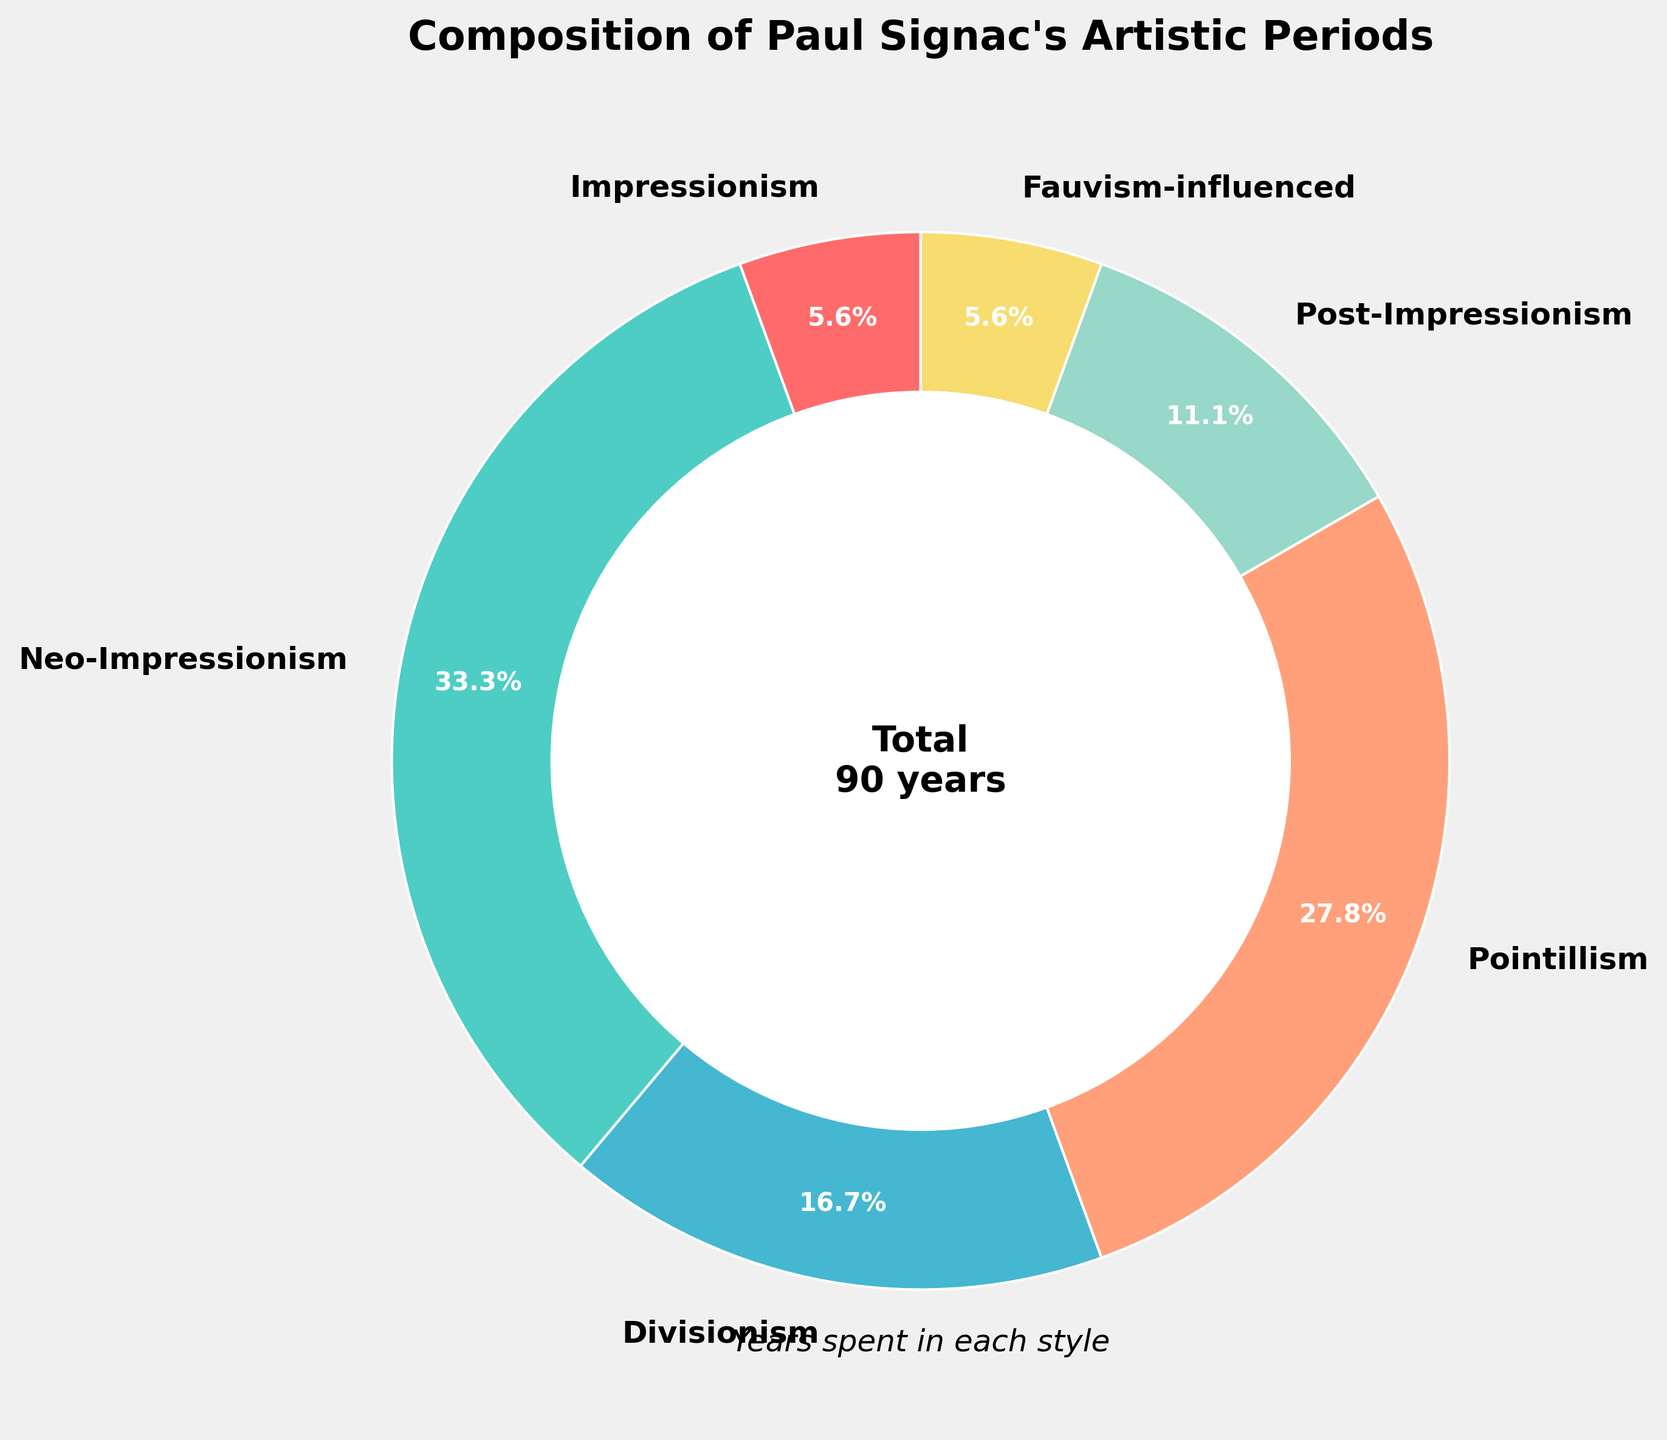Which artistic period did Paul Signac devote the most years to? Examine the segments of the pie chart and identify the largest one. The segment labeled "Neo-Impressionism" represents the largest portion of the chart.
Answer: Neo-Impressionism How many years did Paul Signac spend on periods influenced by Fauvism and Impressionism combined? Locate the segments labeled "Fauvism-influenced" and "Impressionism" on the pie chart. The first has 5 years, and the second also has 5 years. Add these together: 5 + 5 = 10 years.
Answer: 10 Which period occupies a smaller portion, Divisionism or Post-Impressionism? Compare the sizes of the segments labeled "Divisionism" and "Post-Impressionism" on the pie chart. Divisionism has 15 years, whereas Post-Impressionism has 10 years, so Post-Impressionism is smaller.
Answer: Post-Impressionism What percentage of Paul Signac’s artistic periods does the Pointillism style cover? Look at the pie chart segment labeled "Pointillism." The number inside the segment indicates the percentage it covers, which is 25%.
Answer: 25% What is the difference in years between the time spent on Neo-Impressionism and Pointillism? Identify the segments labeled "Neo-Impressionism" and "Pointillism" on the pie chart. Neo-Impressionism has 30 years and Pointillism has 25 years. Subtract the smaller number from the larger: 30 - 25 = 5 years.
Answer: 5 Which period has equal years spent compared to the Impressionism period? Look at the segments on the pie chart and find the one with the same number of years as Impressionism, which is 5 years. The segment "Fauvism-influenced" also has 5 years.
Answer: Fauvism-influenced What is the average number of years spent on Neo-Impressionism, Divisionism, and Pointillism? Calculate the average by adding the years spent in Neo-Impressionism (30 years), Divisionism (15 years), and Pointillism (25 years), then divide by the number of periods (3). (30 + 15 + 25) / 3 = 70 / 3 = approximately 23.33 years.
Answer: 23.33 Which color represents the Post-Impressionism period in the pie chart? Observe the color legend or the segment labeled "Post-Impressionism" on the pie chart. The Post-Impressionism section is marked with a specific color, which is identified visually.
Answer: Orange (or a color description provided) What is the total number of years depicted in the pie chart? Look at the center of the pie chart where the total number of years is indicated. The text displays "Total 90 years."
Answer: 90 Between Divisionism and Neo-Impressionism, which period shows a greater percentage contribution to Signac’s artistic timeline? Compare the percentages associated with the labels "Divisionism" and "Neo-Impressionism" on the pie chart. Neo-Impressionism has a higher percentage (represented by a larger segment).
Answer: Neo-Impressionism 